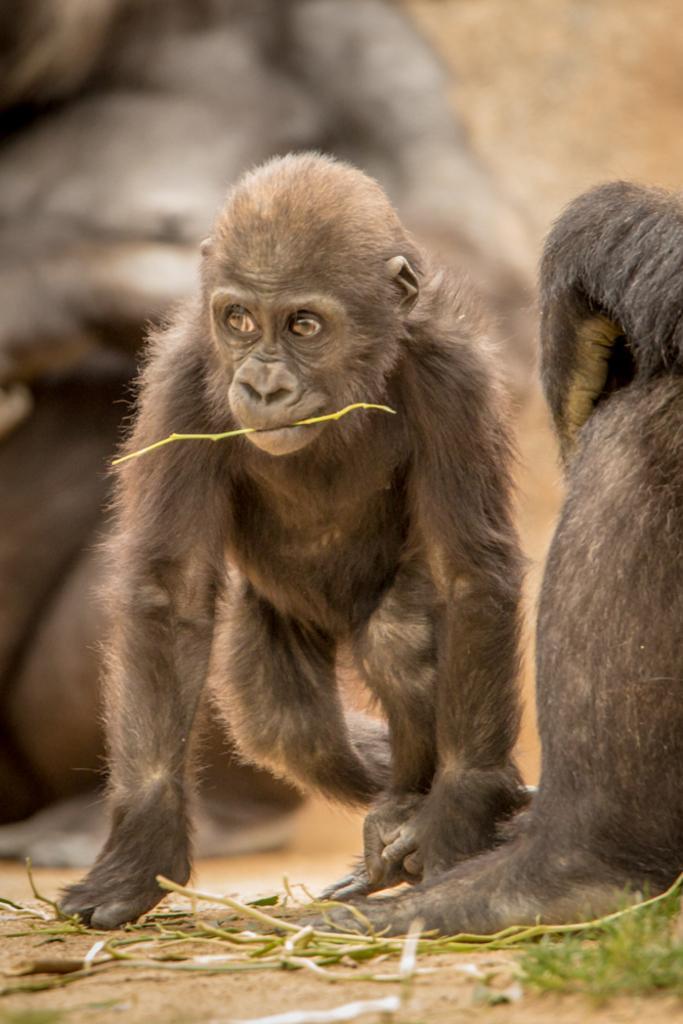Describe this image in one or two sentences. In this picture we can observe gorillas which are in brown color. We can observe some plant stems on the ground. The background is blurred. 